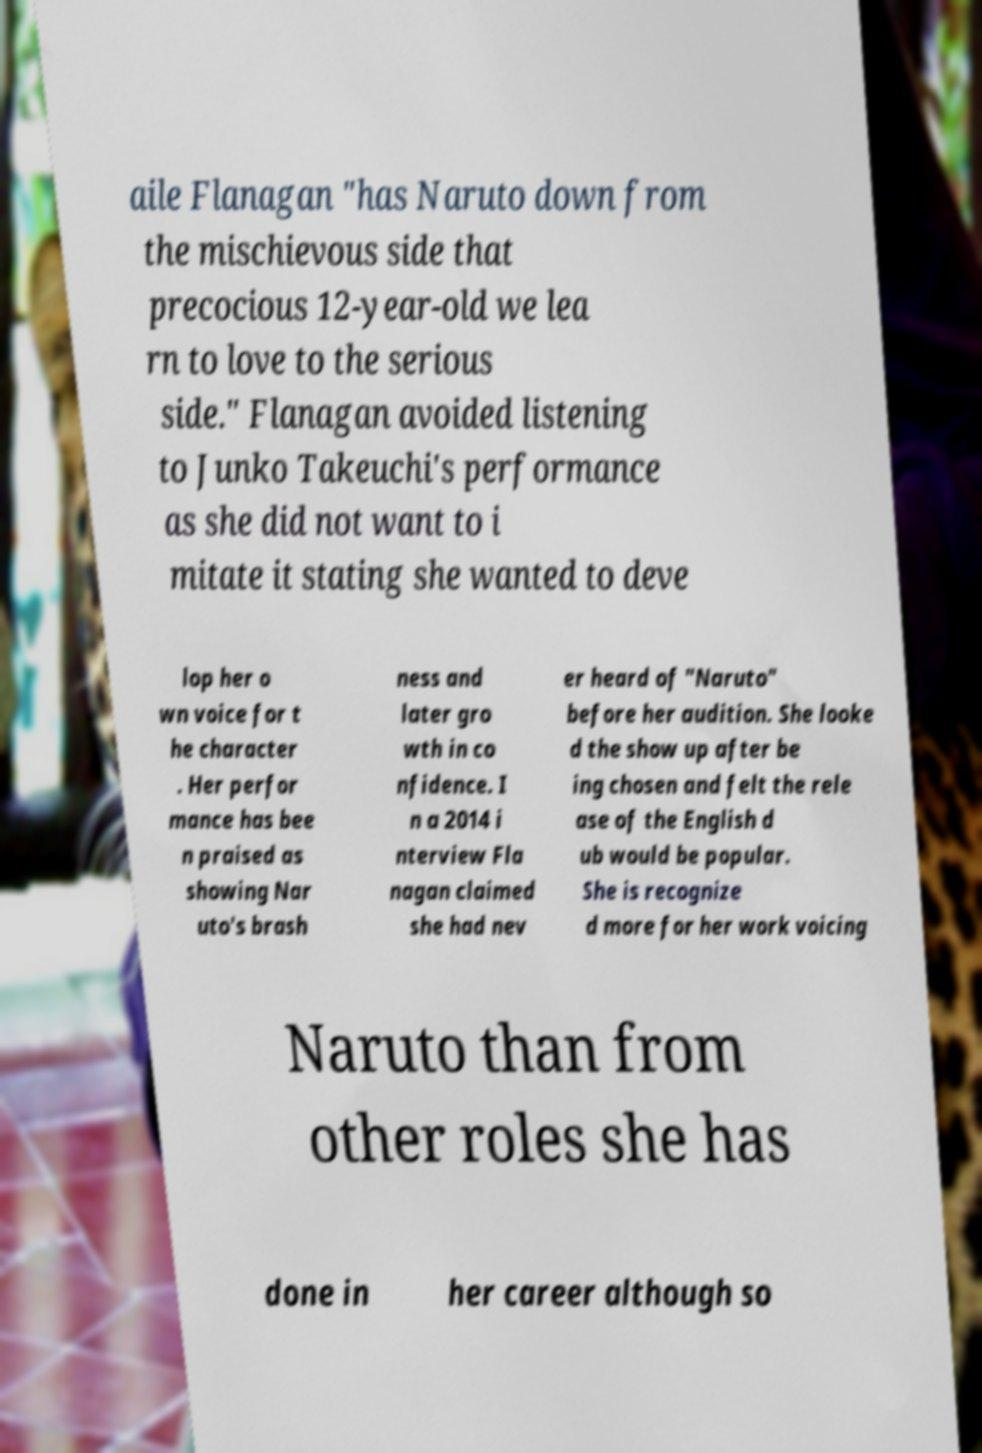Can you accurately transcribe the text from the provided image for me? aile Flanagan "has Naruto down from the mischievous side that precocious 12-year-old we lea rn to love to the serious side." Flanagan avoided listening to Junko Takeuchi's performance as she did not want to i mitate it stating she wanted to deve lop her o wn voice for t he character . Her perfor mance has bee n praised as showing Nar uto's brash ness and later gro wth in co nfidence. I n a 2014 i nterview Fla nagan claimed she had nev er heard of "Naruto" before her audition. She looke d the show up after be ing chosen and felt the rele ase of the English d ub would be popular. She is recognize d more for her work voicing Naruto than from other roles she has done in her career although so 